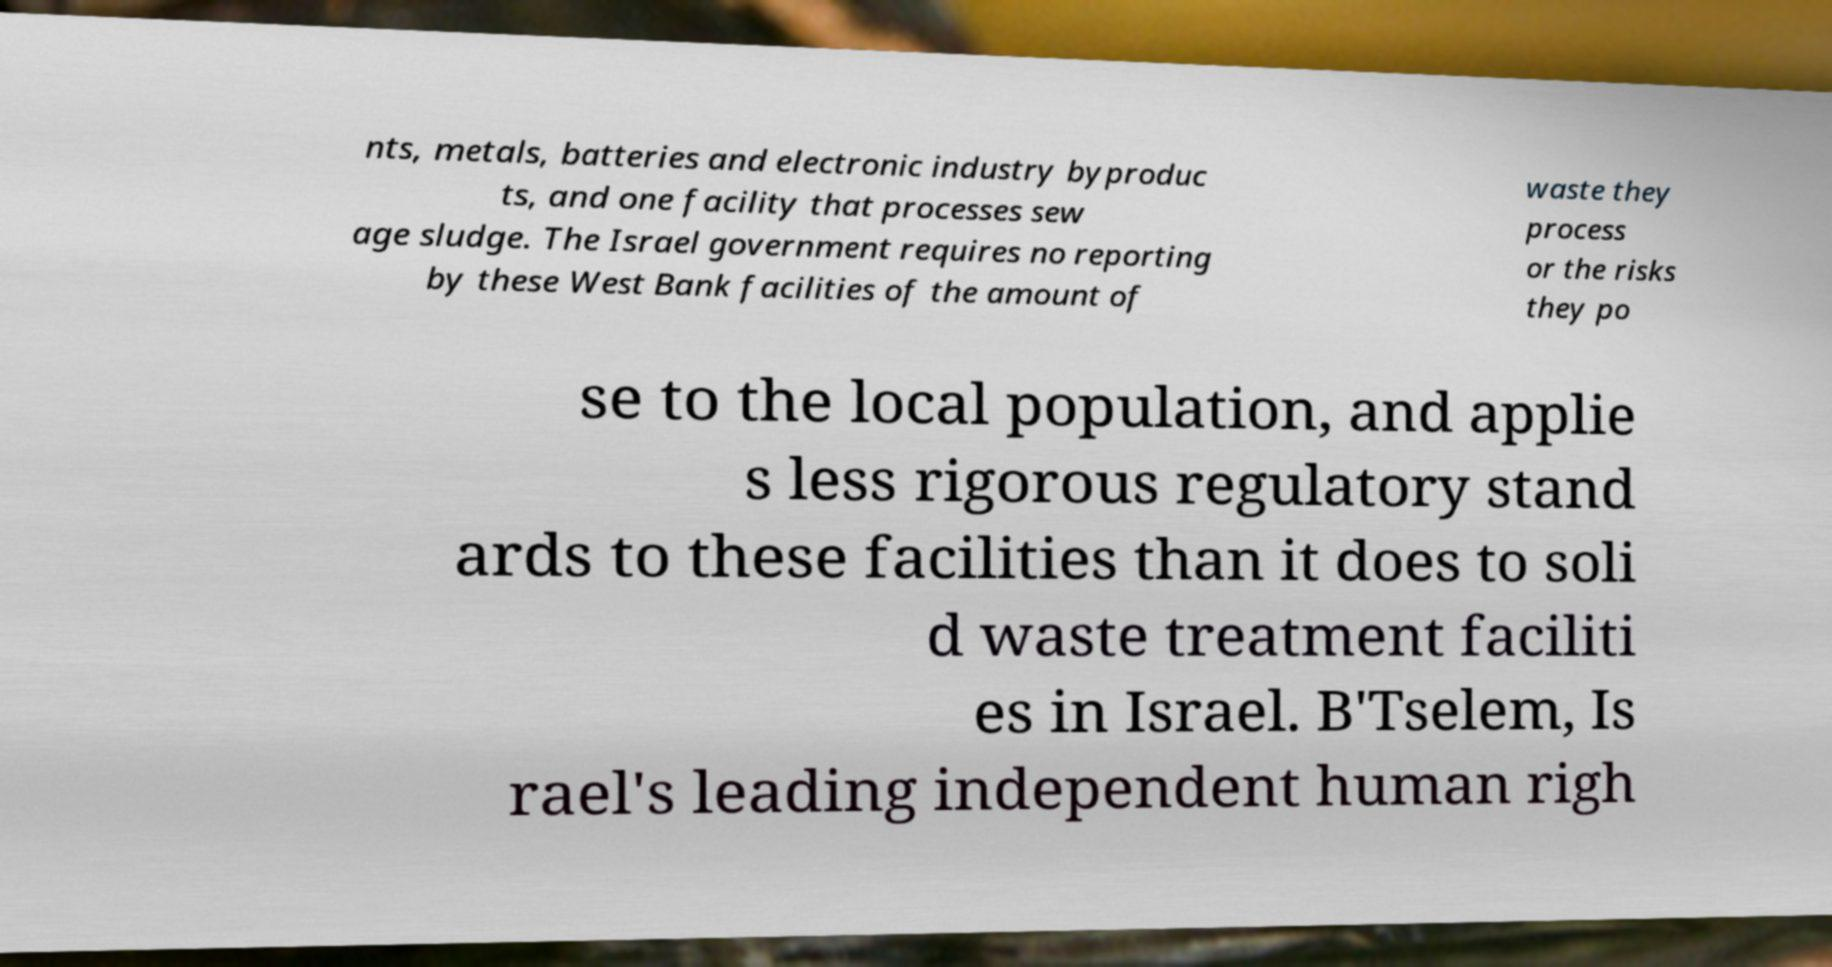Please identify and transcribe the text found in this image. nts, metals, batteries and electronic industry byproduc ts, and one facility that processes sew age sludge. The Israel government requires no reporting by these West Bank facilities of the amount of waste they process or the risks they po se to the local population, and applie s less rigorous regulatory stand ards to these facilities than it does to soli d waste treatment faciliti es in Israel. B'Tselem, Is rael's leading independent human righ 